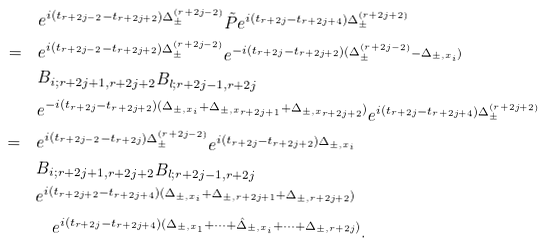<formula> <loc_0><loc_0><loc_500><loc_500>& e ^ { i ( t _ { r + 2 j - 2 } - t _ { r + 2 j + 2 } ) \Delta _ { \pm } ^ { ( r + 2 j - 2 ) } } \tilde { P } e ^ { i ( t _ { r + 2 j } - t _ { r + 2 j + 4 } ) \Delta _ { \pm } ^ { ( r + 2 j + 2 ) } } \\ = \quad & e ^ { i ( t _ { r + 2 j - 2 } - t _ { r + 2 j + 2 } ) \Delta _ { \pm } ^ { ( r + 2 j - 2 ) } } e ^ { - i ( t _ { r + 2 j } - t _ { r + 2 j + 2 } ) ( \Delta _ { \pm } ^ { ( r + 2 j - 2 ) } - \Delta _ { \pm , x _ { i } } ) } \\ & B _ { i ; r + 2 j + 1 , r + 2 j + 2 } B _ { l ; r + 2 j - 1 , r + 2 j } \\ & e ^ { - i ( t _ { r + 2 j } - t _ { r + 2 j + 2 } ) ( \Delta _ { \pm , x _ { i } } + \Delta _ { \pm , x _ { r + 2 j + 1 } } + \Delta _ { \pm , x _ { r + 2 j + 2 } } ) } e ^ { i ( t _ { r + 2 j } - t _ { r + 2 j + 4 } ) \Delta _ { \pm } ^ { ( r + 2 j + 2 ) } } \\ = \quad & e ^ { i ( t _ { r + 2 j - 2 } - t _ { r + 2 j } ) \Delta _ { \pm } ^ { ( r + 2 j - 2 ) } } e ^ { i ( t _ { r + 2 j } - t _ { r + 2 j + 2 } ) \Delta _ { \pm , x _ { i } } } \\ & B _ { i ; r + 2 j + 1 , r + 2 j + 2 } B _ { l ; r + 2 j - 1 , r + 2 j } \\ & e ^ { i ( t _ { r + 2 j + 2 } - t _ { r + 2 j + 4 } ) ( \Delta _ { \pm , x _ { i } } + \Delta _ { \pm , r + 2 j + 1 } + \Delta _ { \pm , r + 2 j + 2 } ) } \\ & \quad e ^ { i ( t _ { r + 2 j } - t _ { r + 2 j + 4 } ) ( \Delta _ { \pm , x _ { 1 } } + \dots + \hat { \Delta } _ { \pm , x _ { i } } + \dots + \Delta _ { \pm , r + 2 j } ) } .</formula> 